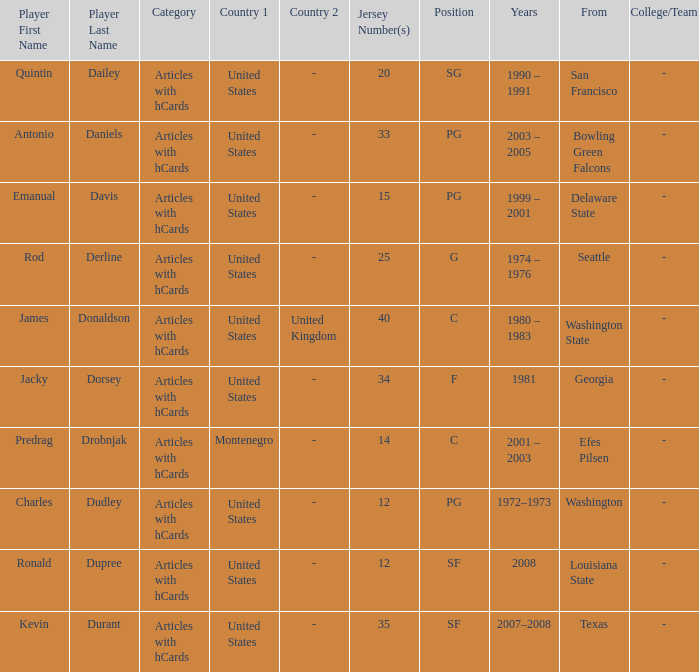What was the nationality of the players with a position of g? United States. Could you parse the entire table? {'header': ['Player First Name', 'Player Last Name', 'Category', 'Country 1', 'Country 2', 'Jersey Number(s)', 'Position', 'Years', 'From', 'College/Team'], 'rows': [['Quintin', 'Dailey', 'Articles with hCards', 'United States', '-', '20', 'SG', '1990 – 1991', 'San Francisco', '-'], ['Antonio', 'Daniels', 'Articles with hCards', 'United States', '-', '33', 'PG', '2003 – 2005', 'Bowling Green Falcons', '-'], ['Emanual', 'Davis', 'Articles with hCards', 'United States', '-', '15', 'PG', '1999 – 2001', 'Delaware State', '-'], ['Rod', 'Derline', 'Articles with hCards', 'United States', '-', '25', 'G', '1974 – 1976', 'Seattle', '-'], ['James', 'Donaldson', 'Articles with hCards', 'United States', 'United Kingdom', '40', 'C', '1980 – 1983', 'Washington State', '-'], ['Jacky', 'Dorsey', 'Articles with hCards', 'United States', '-', '34', 'F', '1981', 'Georgia', '-'], ['Predrag', 'Drobnjak', 'Articles with hCards', 'Montenegro', '-', '14', 'C', '2001 – 2003', 'Efes Pilsen', '-'], ['Charles', 'Dudley', 'Articles with hCards', 'United States', '-', '12', 'PG', '1972–1973', 'Washington', '-'], ['Ronald', 'Dupree', 'Articles with hCards', 'United States', '-', '12', 'SF', '2008', 'Louisiana State', '-'], ['Kevin', 'Durant', 'Articles with hCards', 'United States', '-', '35', 'SF', '2007–2008', 'Texas', '-']]} 